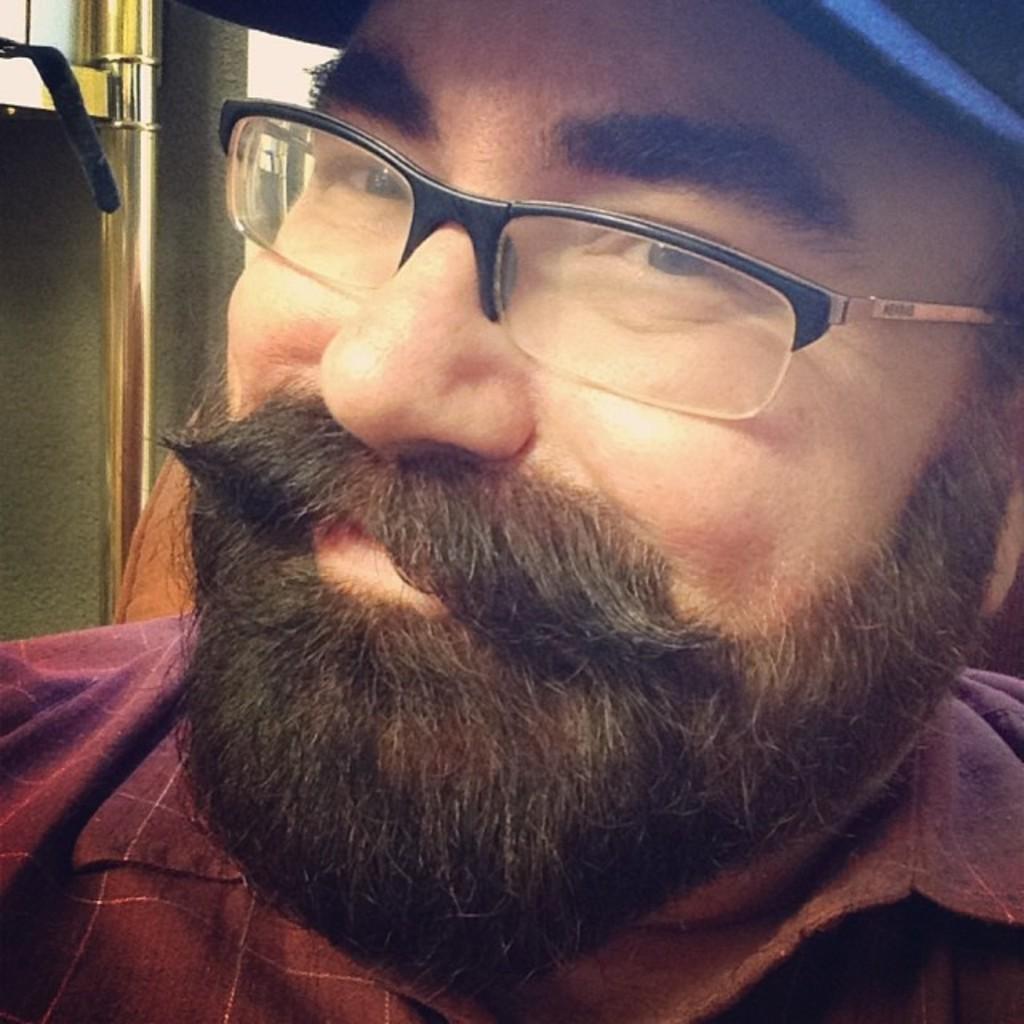In one or two sentences, can you explain what this image depicts? Here I can see a man wearing a shirt, cap on the head, spectacles, smiling and giving pose for the picture. At the back of this man there is a metal stand. 